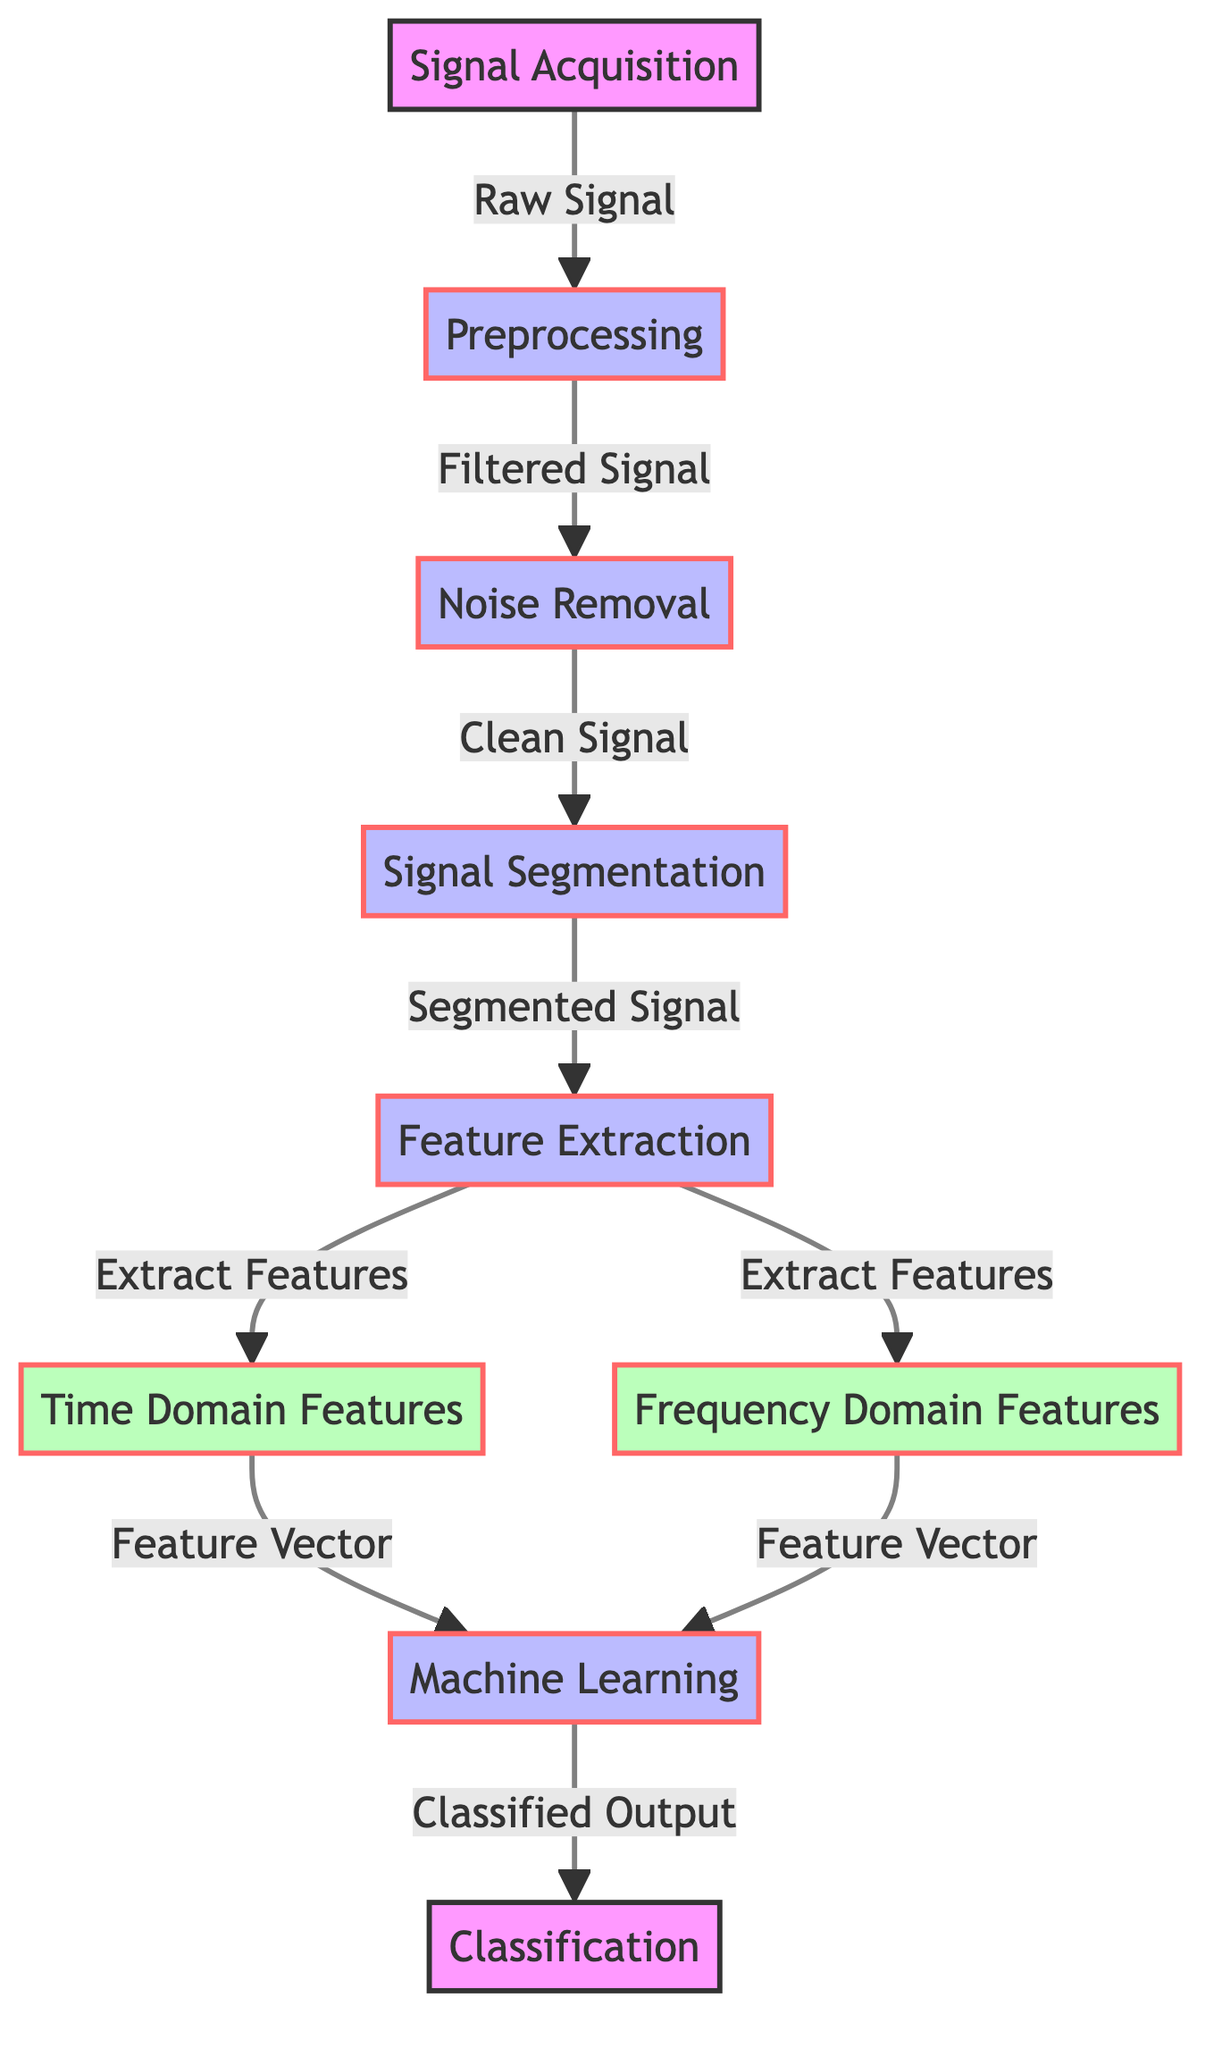What are the first two stages of processing in the diagram? The first two stages are "Signal Acquisition" followed by "Preprocessing". This can be seen as the initial steps in the flow of the diagram, starting from the left.
Answer: Signal Acquisition, Preprocessing How many features are extracted in the feature extraction stage? In the "Feature Extraction" stage, two types of features are extracted: "Time Domain Features" and "Frequency Domain Features". This information can be traced by looking at the connections leading from the "Feature Extraction" node.
Answer: Two What is the output from the "Machine Learning" stage? The "Machine Learning" stage provides a "Classified Output". This is the output that is indicated by the arrow leading to the next node, "Classification".
Answer: Classified Output Which stage immediately follows noise removal? The stage that immediately follows "Noise Removal" is "Signal Segmentation". This can be determined by looking at the connections in the linear flow of the diagram.
Answer: Signal Segmentation What type of processing occurs after signal segmentation? After "Signal Segmentation", the next type of processing that occurs is "Feature Extraction". This can be directly visualized in the sequence of steps indicated in the diagram.
Answer: Feature Extraction How many nodes are classified as feature nodes in the diagram? There are two feature nodes in the diagram: "Time Domain Features" and "Frequency Domain Features". These nodes can be counted directly as they are visually distinct in the diagram.
Answer: Two What is the relationship between "Feature Extraction" and "Machine Learning"? The relationship is that "Feature Extraction" outputs feature vectors (from both time domain and frequency domain) that serve as inputs to "Machine Learning". This flow can be traced through the arrows connecting the two nodes.
Answer: Feature vector input What is the last stage in the processing flow of the diagram? The last stage in the processing flow is "Classification". This is the final node that is indicated at the right end of the flow diagram.
Answer: Classification 